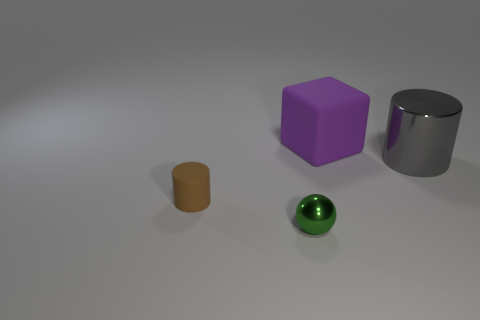Add 1 big objects. How many objects exist? 5 Subtract all brown cylinders. How many cylinders are left? 1 Add 4 small green shiny things. How many small green shiny things are left? 5 Add 1 purple rubber blocks. How many purple rubber blocks exist? 2 Subtract 0 blue spheres. How many objects are left? 4 Subtract all cubes. How many objects are left? 3 Subtract all green cylinders. Subtract all green balls. How many cylinders are left? 2 Subtract all big brown shiny things. Subtract all tiny green shiny objects. How many objects are left? 3 